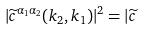Convert formula to latex. <formula><loc_0><loc_0><loc_500><loc_500>| \widetilde { c } ^ { \alpha _ { 1 } \alpha _ { 2 } } ( k _ { 2 } , k _ { 1 } ) | ^ { 2 } = | \widetilde { c }</formula> 